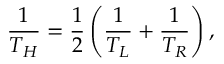<formula> <loc_0><loc_0><loc_500><loc_500>\frac { 1 } { T _ { H } } = \frac { 1 } { 2 } \left ( \frac { 1 } { T _ { L } } + \frac { 1 } { T _ { R } } \right ) ,</formula> 